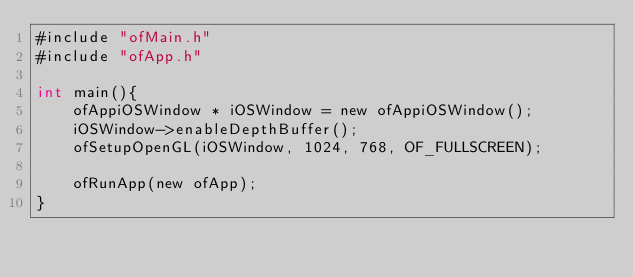Convert code to text. <code><loc_0><loc_0><loc_500><loc_500><_ObjectiveC_>#include "ofMain.h"
#include "ofApp.h"

int main(){
    ofAppiOSWindow * iOSWindow = new ofAppiOSWindow();
    iOSWindow->enableDepthBuffer();
    ofSetupOpenGL(iOSWindow, 1024, 768, OF_FULLSCREEN);
    
    ofRunApp(new ofApp);
}
</code> 